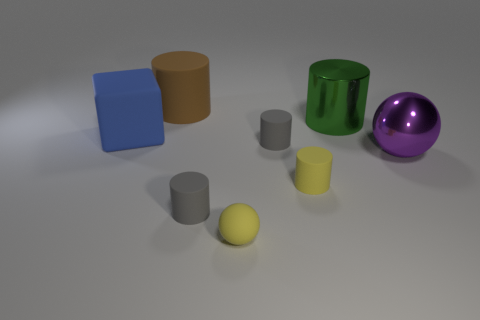Which of the objects in the image appears to be the largest? The green cylinder appears to be the largest object, with its notable height and width in comparison to the other items. 